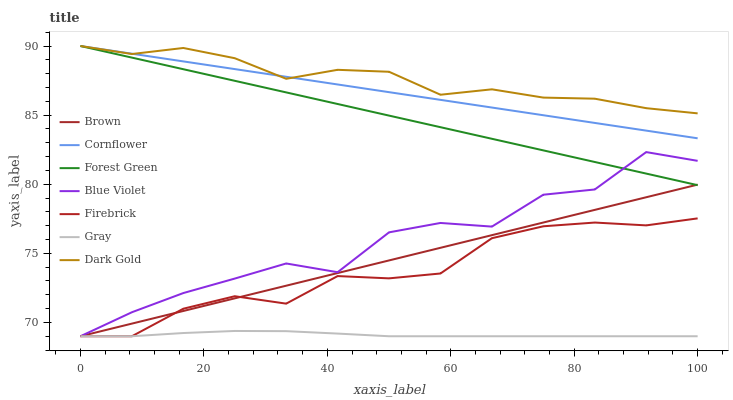Does Gray have the minimum area under the curve?
Answer yes or no. Yes. Does Dark Gold have the maximum area under the curve?
Answer yes or no. Yes. Does Firebrick have the minimum area under the curve?
Answer yes or no. No. Does Firebrick have the maximum area under the curve?
Answer yes or no. No. Is Brown the smoothest?
Answer yes or no. Yes. Is Blue Violet the roughest?
Answer yes or no. Yes. Is Gray the smoothest?
Answer yes or no. No. Is Gray the roughest?
Answer yes or no. No. Does Brown have the lowest value?
Answer yes or no. Yes. Does Dark Gold have the lowest value?
Answer yes or no. No. Does Cornflower have the highest value?
Answer yes or no. Yes. Does Firebrick have the highest value?
Answer yes or no. No. Is Gray less than Forest Green?
Answer yes or no. Yes. Is Dark Gold greater than Gray?
Answer yes or no. Yes. Does Firebrick intersect Gray?
Answer yes or no. Yes. Is Firebrick less than Gray?
Answer yes or no. No. Is Firebrick greater than Gray?
Answer yes or no. No. Does Gray intersect Forest Green?
Answer yes or no. No. 